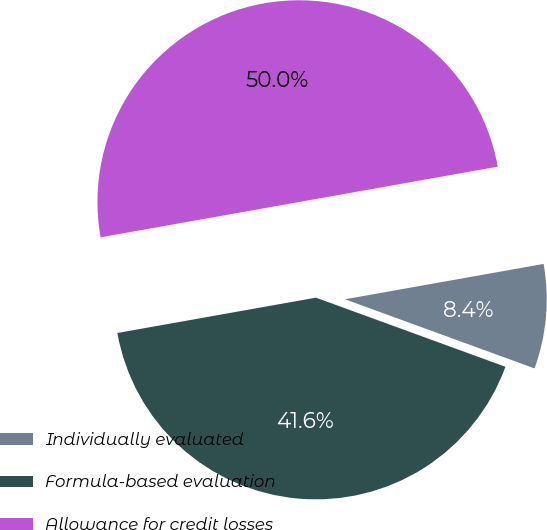Convert chart to OTSL. <chart><loc_0><loc_0><loc_500><loc_500><pie_chart><fcel>Individually evaluated<fcel>Formula-based evaluation<fcel>Allowance for credit losses<nl><fcel>8.37%<fcel>41.63%<fcel>50.0%<nl></chart> 